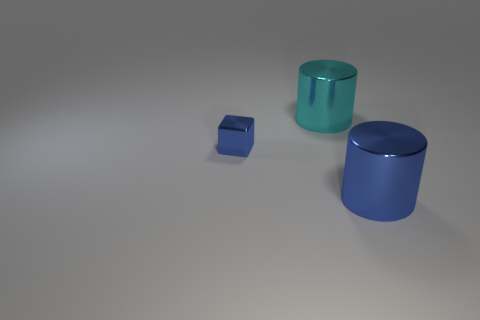Is there any other thing that has the same size as the blue shiny block?
Offer a very short reply. No. There is a big metal thing in front of the small blue metal object; is there a blue cylinder that is to the right of it?
Your answer should be compact. No. The cyan thing is what shape?
Make the answer very short. Cylinder. How big is the blue metal thing behind the large shiny thing that is in front of the tiny blue metal block?
Keep it short and to the point. Small. There is a metallic cylinder in front of the cyan metal cylinder; what is its size?
Your response must be concise. Large. Are there fewer large blue things that are in front of the cyan metal cylinder than objects on the right side of the tiny shiny cube?
Offer a very short reply. Yes. The block is what color?
Provide a succinct answer. Blue. Is there a big cylinder of the same color as the tiny metallic object?
Provide a short and direct response. Yes. What is the shape of the blue shiny thing on the right side of the large metallic cylinder that is on the left side of the object to the right of the big cyan shiny thing?
Keep it short and to the point. Cylinder. There is a big cylinder that is behind the tiny metal object; what is its material?
Your answer should be very brief. Metal. 